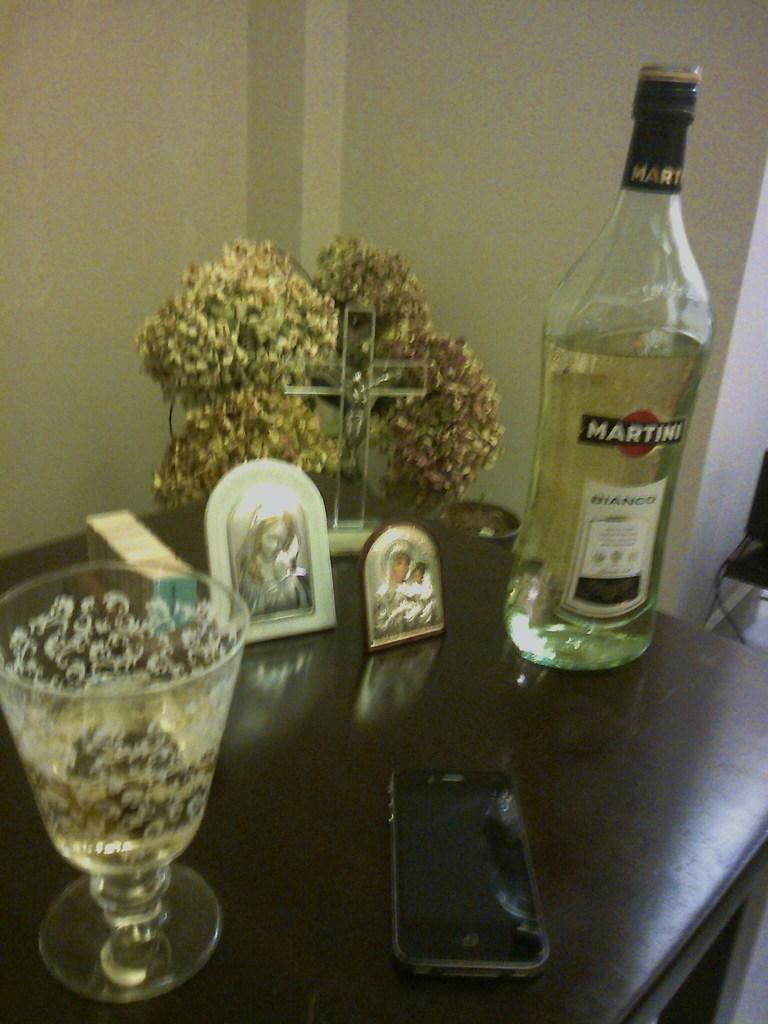What objects can be seen in the image? There is a bottle, a glass, a mobile phone, and two photo frames on the table in the image. What is the background of the image like? There is a wall and a pillar in the background of the image. Is the person in the image currently on vacation? There is no person visible in the image, so it cannot be determined if they are on vacation. Can you tell me how many people are in jail based on the image? There is no reference to a jail or any people in the image, so it cannot be determined how many people are in jail. 